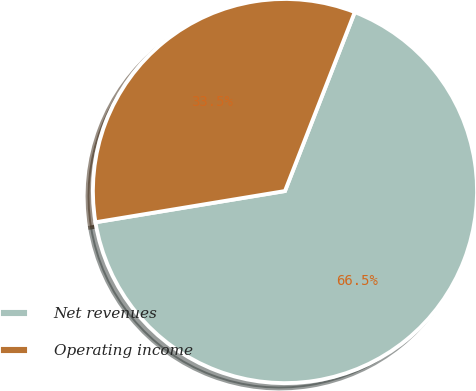<chart> <loc_0><loc_0><loc_500><loc_500><pie_chart><fcel>Net revenues<fcel>Operating income<nl><fcel>66.48%<fcel>33.52%<nl></chart> 